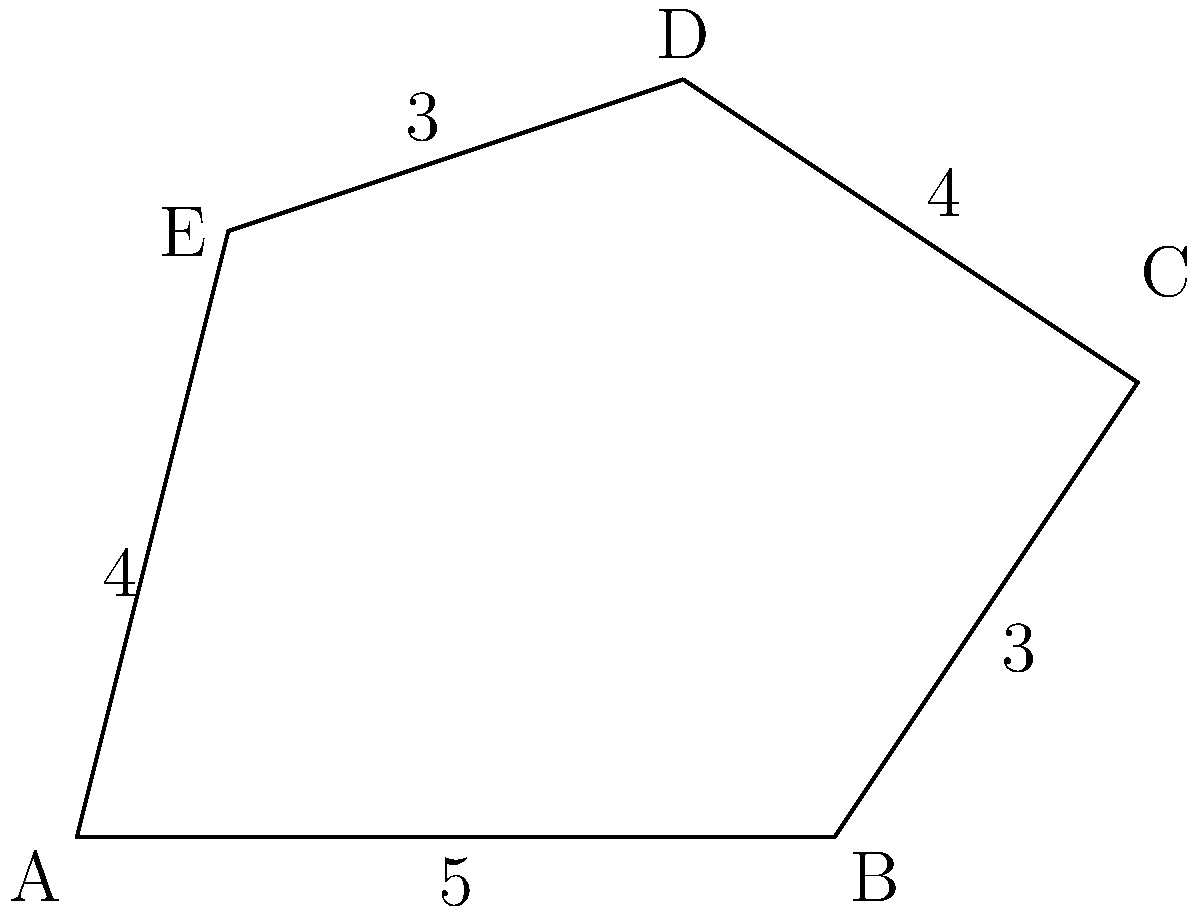In your collaborative work on incorporating genealogical information into a memoir, you've come across an irregularly shaped ancestral property map. The property is represented by the pentagonal shape ABCDE in the diagram. Given that AB = 5 units, BC = 3 units, CD = 4 units, DE = 3 units, and EA = 4 units, what is the perimeter of the entire property? To calculate the perimeter of the irregularly shaped ancestral property, we need to sum up the lengths of all sides of the pentagonal shape ABCDE. Let's break it down step by step:

1. Side AB: $5$ units
2. Side BC: $3$ units
3. Side CD: $4$ units
4. Side DE: $3$ units
5. Side EA: $4$ units

Now, we can add all these lengths together:

$$\text{Perimeter} = AB + BC + CD + DE + EA$$
$$\text{Perimeter} = 5 + 3 + 4 + 3 + 4$$
$$\text{Perimeter} = 19 \text{ units}$$

Therefore, the perimeter of the entire ancestral property is 19 units.
Answer: 19 units 